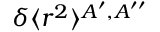Convert formula to latex. <formula><loc_0><loc_0><loc_500><loc_500>\delta \langle r ^ { 2 } \rangle ^ { A ^ { \prime } , A ^ { \prime \prime } }</formula> 